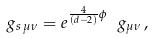<formula> <loc_0><loc_0><loc_500><loc_500>g _ { s \, \mu \nu } = e ^ { \frac { 4 } { ( d - 2 ) } \phi } \ g _ { \mu \nu } \, ,</formula> 